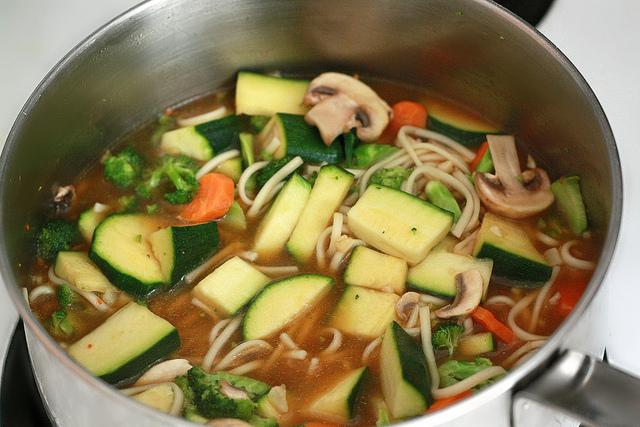What vegetables are in the pot?
Keep it brief. Zucchini, carrots, broccoli. Is the soup boiling?
Give a very brief answer. No. Would a vegetarian eat this?
Keep it brief. Yes. 